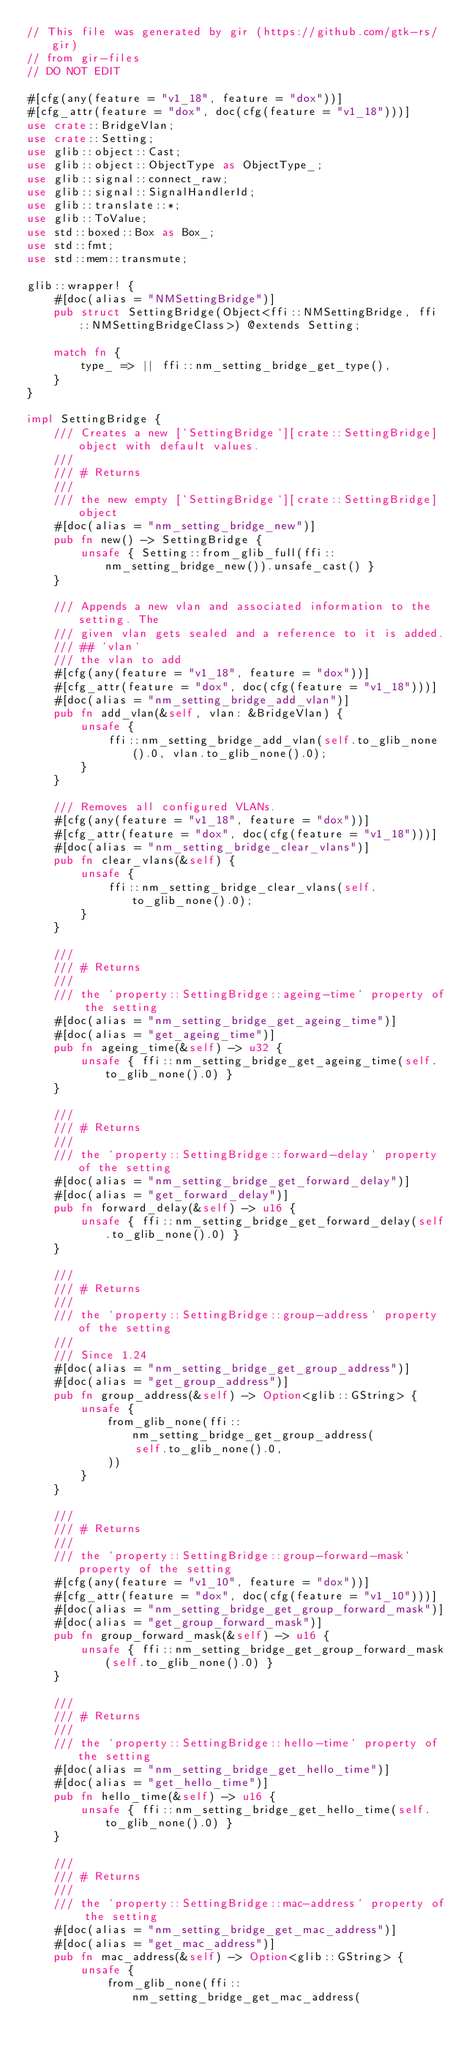Convert code to text. <code><loc_0><loc_0><loc_500><loc_500><_Rust_>// This file was generated by gir (https://github.com/gtk-rs/gir)
// from gir-files
// DO NOT EDIT

#[cfg(any(feature = "v1_18", feature = "dox"))]
#[cfg_attr(feature = "dox", doc(cfg(feature = "v1_18")))]
use crate::BridgeVlan;
use crate::Setting;
use glib::object::Cast;
use glib::object::ObjectType as ObjectType_;
use glib::signal::connect_raw;
use glib::signal::SignalHandlerId;
use glib::translate::*;
use glib::ToValue;
use std::boxed::Box as Box_;
use std::fmt;
use std::mem::transmute;

glib::wrapper! {
    #[doc(alias = "NMSettingBridge")]
    pub struct SettingBridge(Object<ffi::NMSettingBridge, ffi::NMSettingBridgeClass>) @extends Setting;

    match fn {
        type_ => || ffi::nm_setting_bridge_get_type(),
    }
}

impl SettingBridge {
    /// Creates a new [`SettingBridge`][crate::SettingBridge] object with default values.
    ///
    /// # Returns
    ///
    /// the new empty [`SettingBridge`][crate::SettingBridge] object
    #[doc(alias = "nm_setting_bridge_new")]
    pub fn new() -> SettingBridge {
        unsafe { Setting::from_glib_full(ffi::nm_setting_bridge_new()).unsafe_cast() }
    }

    /// Appends a new vlan and associated information to the setting. The
    /// given vlan gets sealed and a reference to it is added.
    /// ## `vlan`
    /// the vlan to add
    #[cfg(any(feature = "v1_18", feature = "dox"))]
    #[cfg_attr(feature = "dox", doc(cfg(feature = "v1_18")))]
    #[doc(alias = "nm_setting_bridge_add_vlan")]
    pub fn add_vlan(&self, vlan: &BridgeVlan) {
        unsafe {
            ffi::nm_setting_bridge_add_vlan(self.to_glib_none().0, vlan.to_glib_none().0);
        }
    }

    /// Removes all configured VLANs.
    #[cfg(any(feature = "v1_18", feature = "dox"))]
    #[cfg_attr(feature = "dox", doc(cfg(feature = "v1_18")))]
    #[doc(alias = "nm_setting_bridge_clear_vlans")]
    pub fn clear_vlans(&self) {
        unsafe {
            ffi::nm_setting_bridge_clear_vlans(self.to_glib_none().0);
        }
    }

    ///
    /// # Returns
    ///
    /// the `property::SettingBridge::ageing-time` property of the setting
    #[doc(alias = "nm_setting_bridge_get_ageing_time")]
    #[doc(alias = "get_ageing_time")]
    pub fn ageing_time(&self) -> u32 {
        unsafe { ffi::nm_setting_bridge_get_ageing_time(self.to_glib_none().0) }
    }

    ///
    /// # Returns
    ///
    /// the `property::SettingBridge::forward-delay` property of the setting
    #[doc(alias = "nm_setting_bridge_get_forward_delay")]
    #[doc(alias = "get_forward_delay")]
    pub fn forward_delay(&self) -> u16 {
        unsafe { ffi::nm_setting_bridge_get_forward_delay(self.to_glib_none().0) }
    }

    ///
    /// # Returns
    ///
    /// the `property::SettingBridge::group-address` property of the setting
    ///
    /// Since 1.24
    #[doc(alias = "nm_setting_bridge_get_group_address")]
    #[doc(alias = "get_group_address")]
    pub fn group_address(&self) -> Option<glib::GString> {
        unsafe {
            from_glib_none(ffi::nm_setting_bridge_get_group_address(
                self.to_glib_none().0,
            ))
        }
    }

    ///
    /// # Returns
    ///
    /// the `property::SettingBridge::group-forward-mask` property of the setting
    #[cfg(any(feature = "v1_10", feature = "dox"))]
    #[cfg_attr(feature = "dox", doc(cfg(feature = "v1_10")))]
    #[doc(alias = "nm_setting_bridge_get_group_forward_mask")]
    #[doc(alias = "get_group_forward_mask")]
    pub fn group_forward_mask(&self) -> u16 {
        unsafe { ffi::nm_setting_bridge_get_group_forward_mask(self.to_glib_none().0) }
    }

    ///
    /// # Returns
    ///
    /// the `property::SettingBridge::hello-time` property of the setting
    #[doc(alias = "nm_setting_bridge_get_hello_time")]
    #[doc(alias = "get_hello_time")]
    pub fn hello_time(&self) -> u16 {
        unsafe { ffi::nm_setting_bridge_get_hello_time(self.to_glib_none().0) }
    }

    ///
    /// # Returns
    ///
    /// the `property::SettingBridge::mac-address` property of the setting
    #[doc(alias = "nm_setting_bridge_get_mac_address")]
    #[doc(alias = "get_mac_address")]
    pub fn mac_address(&self) -> Option<glib::GString> {
        unsafe {
            from_glib_none(ffi::nm_setting_bridge_get_mac_address(</code> 